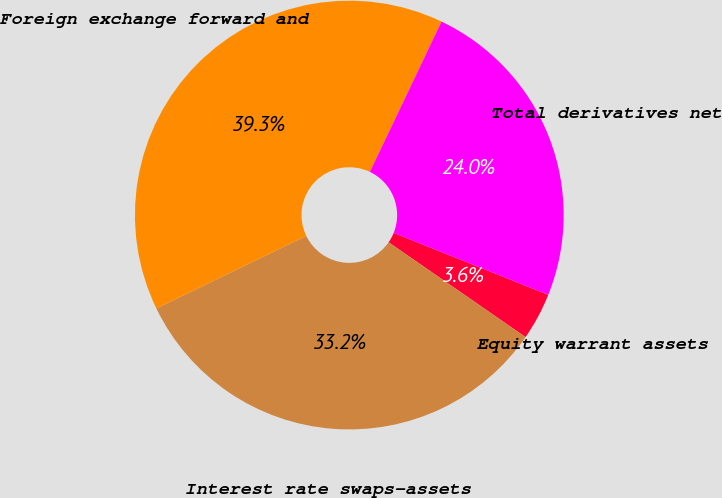Convert chart. <chart><loc_0><loc_0><loc_500><loc_500><pie_chart><fcel>Equity warrant assets<fcel>Interest rate swaps-assets<fcel>Foreign exchange forward and<fcel>Total derivatives net<nl><fcel>3.57%<fcel>33.18%<fcel>39.26%<fcel>23.99%<nl></chart> 